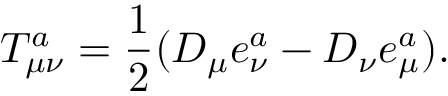Convert formula to latex. <formula><loc_0><loc_0><loc_500><loc_500>T _ { \mu \nu } ^ { a } = \frac { 1 } { 2 } ( D _ { \mu } e _ { \nu } ^ { a } - D _ { \nu } e _ { \mu } ^ { a } ) .</formula> 